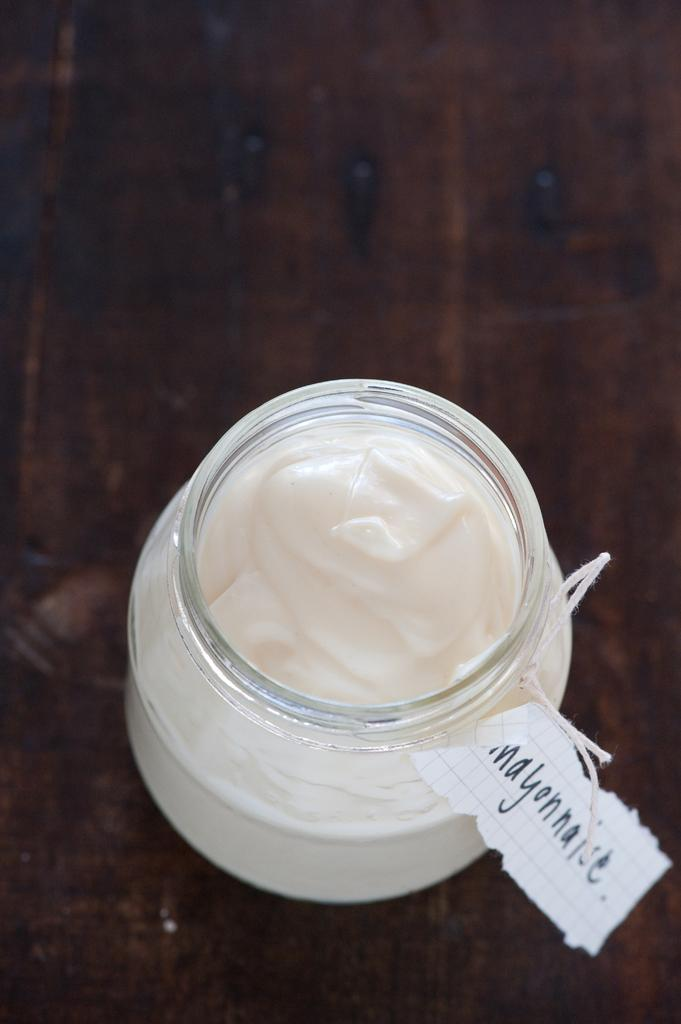<image>
Provide a brief description of the given image. Small jar of homemade mayonnaise with a hand written tag attached. 